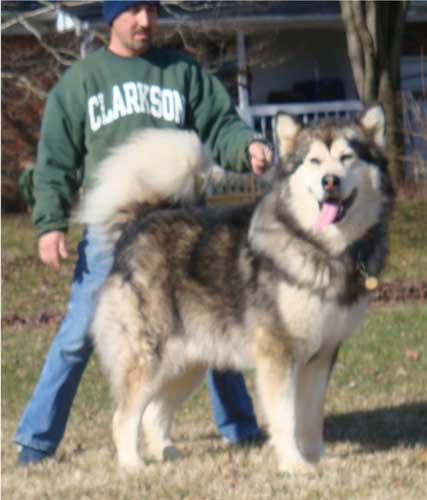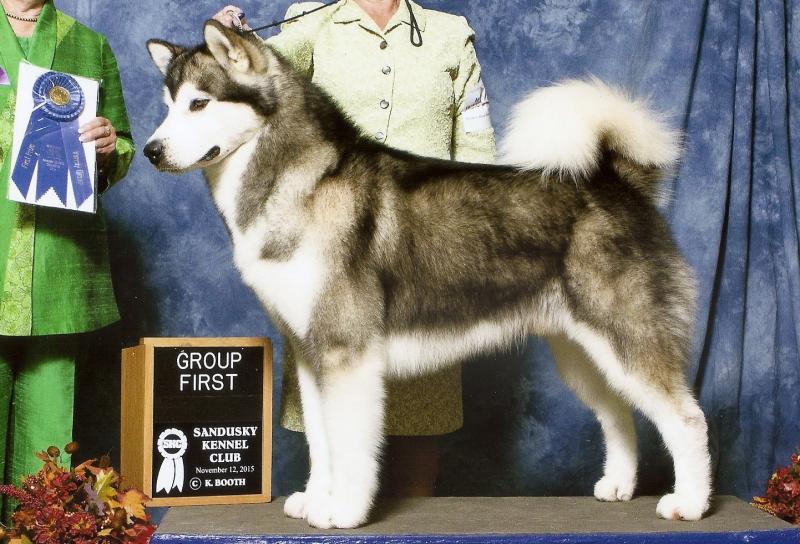The first image is the image on the left, the second image is the image on the right. For the images shown, is this caption "There are dogs standing." true? Answer yes or no. Yes. The first image is the image on the left, the second image is the image on the right. Given the left and right images, does the statement "There are two dogs in the image pair" hold true? Answer yes or no. Yes. 